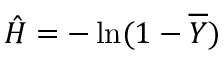<formula> <loc_0><loc_0><loc_500><loc_500>\hat { H } = - \ln ( 1 - \overline { Y } )</formula> 